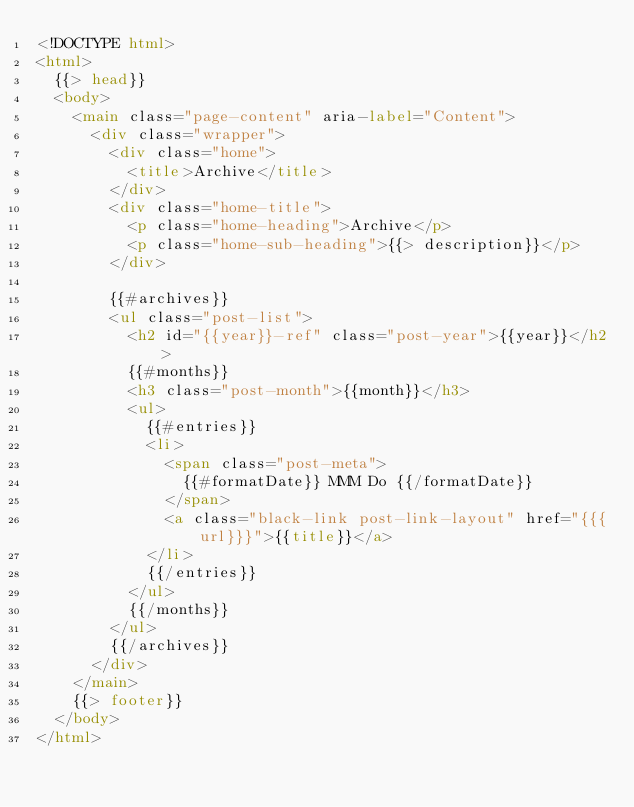<code> <loc_0><loc_0><loc_500><loc_500><_HTML_><!DOCTYPE html>
<html>
  {{> head}}
  <body>
    <main class="page-content" aria-label="Content">
      <div class="wrapper">
        <div class="home">
          <title>Archive</title>
        </div>
        <div class="home-title">
          <p class="home-heading">Archive</p>
          <p class="home-sub-heading">{{> description}}</p>
        </div>

        {{#archives}}
        <ul class="post-list">
          <h2 id="{{year}}-ref" class="post-year">{{year}}</h2>
          {{#months}}
          <h3 class="post-month">{{month}}</h3>
          <ul>
            {{#entries}}
            <li>
              <span class="post-meta">
                {{#formatDate}} MMM Do {{/formatDate}}
              </span>
              <a class="black-link post-link-layout" href="{{{url}}}">{{title}}</a>
            </li>
            {{/entries}}
          </ul>
          {{/months}}
        </ul>
        {{/archives}}
      </div>
    </main>
    {{> footer}}
  </body>
</html>

</code> 